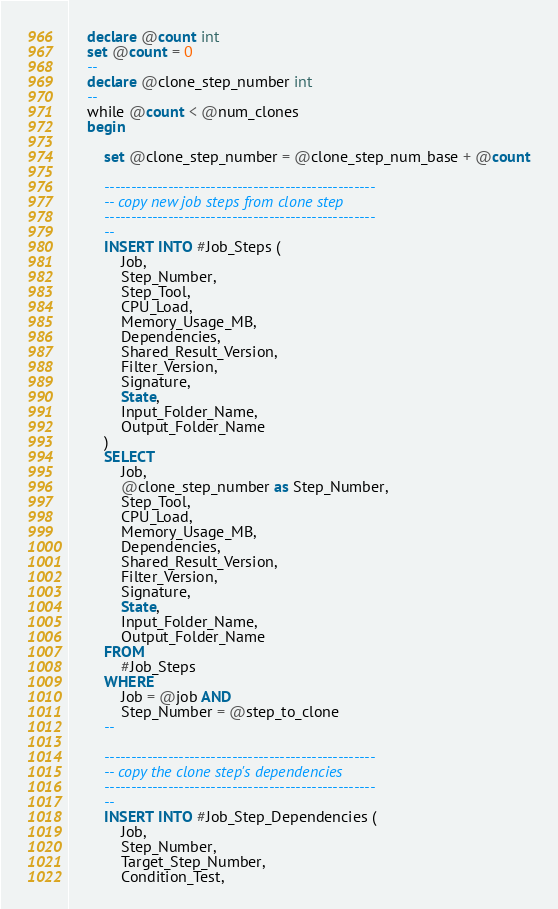Convert code to text. <code><loc_0><loc_0><loc_500><loc_500><_SQL_>	declare @count int
	set @count = 0
	--
	declare @clone_step_number int
	--
	while @count < @num_clones
	begin
	
		set @clone_step_number = @clone_step_num_base + @count

		---------------------------------------------------
		-- copy new job steps from clone step
		---------------------------------------------------
		--
		INSERT INTO #Job_Steps (
			Job,
			Step_Number,
			Step_Tool,
			CPU_Load,
			Memory_Usage_MB,
			Dependencies,
			Shared_Result_Version,
			Filter_Version,
			Signature,
			State,
			Input_Folder_Name,
			Output_Folder_Name
		)
		SELECT 
			Job,
			@clone_step_number as Step_Number,
			Step_Tool,
			CPU_Load,
			Memory_Usage_MB,
			Dependencies,
			Shared_Result_Version,
			Filter_Version,
			Signature,
			State,
			Input_Folder_Name,
			Output_Folder_Name
		FROM   
			#Job_Steps
		WHERE
			Job = @job AND 
			Step_Number = @step_to_clone
		--

		---------------------------------------------------
		-- copy the clone step's dependencies
		---------------------------------------------------
		--
		INSERT INTO #Job_Step_Dependencies (
			Job,
			Step_Number,
			Target_Step_Number,
			Condition_Test,</code> 